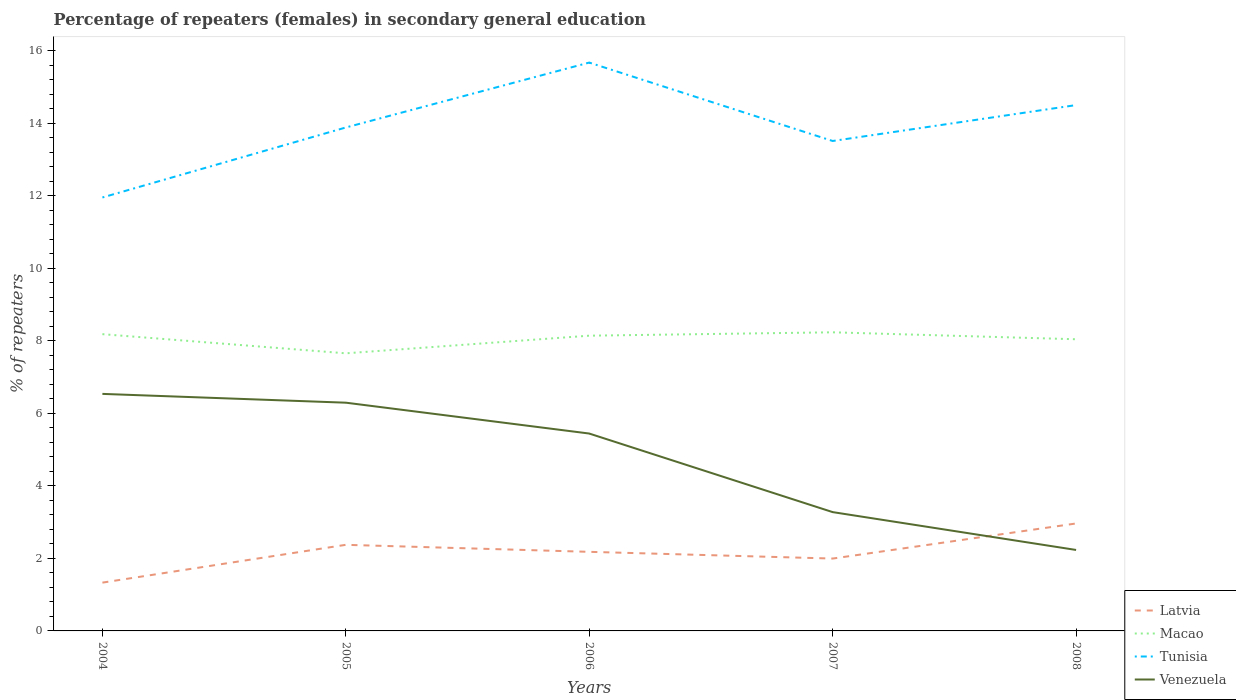Does the line corresponding to Tunisia intersect with the line corresponding to Latvia?
Keep it short and to the point. No. Is the number of lines equal to the number of legend labels?
Your answer should be compact. Yes. Across all years, what is the maximum percentage of female repeaters in Venezuela?
Offer a very short reply. 2.23. In which year was the percentage of female repeaters in Latvia maximum?
Make the answer very short. 2004. What is the total percentage of female repeaters in Venezuela in the graph?
Ensure brevity in your answer.  2.17. What is the difference between the highest and the second highest percentage of female repeaters in Macao?
Your response must be concise. 0.58. What is the difference between the highest and the lowest percentage of female repeaters in Tunisia?
Provide a short and direct response. 2. How many years are there in the graph?
Offer a very short reply. 5. Does the graph contain any zero values?
Offer a terse response. No. Where does the legend appear in the graph?
Make the answer very short. Bottom right. How many legend labels are there?
Offer a terse response. 4. What is the title of the graph?
Your response must be concise. Percentage of repeaters (females) in secondary general education. Does "Croatia" appear as one of the legend labels in the graph?
Ensure brevity in your answer.  No. What is the label or title of the X-axis?
Ensure brevity in your answer.  Years. What is the label or title of the Y-axis?
Your answer should be compact. % of repeaters. What is the % of repeaters in Latvia in 2004?
Your answer should be compact. 1.33. What is the % of repeaters of Macao in 2004?
Your response must be concise. 8.19. What is the % of repeaters of Tunisia in 2004?
Offer a terse response. 11.96. What is the % of repeaters of Venezuela in 2004?
Offer a terse response. 6.54. What is the % of repeaters of Latvia in 2005?
Keep it short and to the point. 2.38. What is the % of repeaters of Macao in 2005?
Ensure brevity in your answer.  7.66. What is the % of repeaters of Tunisia in 2005?
Keep it short and to the point. 13.89. What is the % of repeaters in Venezuela in 2005?
Provide a short and direct response. 6.3. What is the % of repeaters of Latvia in 2006?
Provide a succinct answer. 2.18. What is the % of repeaters in Macao in 2006?
Offer a very short reply. 8.14. What is the % of repeaters of Tunisia in 2006?
Your response must be concise. 15.68. What is the % of repeaters in Venezuela in 2006?
Offer a very short reply. 5.44. What is the % of repeaters in Latvia in 2007?
Make the answer very short. 2. What is the % of repeaters in Macao in 2007?
Provide a short and direct response. 8.24. What is the % of repeaters of Tunisia in 2007?
Keep it short and to the point. 13.52. What is the % of repeaters of Venezuela in 2007?
Offer a terse response. 3.28. What is the % of repeaters in Latvia in 2008?
Provide a short and direct response. 2.96. What is the % of repeaters in Macao in 2008?
Your answer should be compact. 8.05. What is the % of repeaters of Tunisia in 2008?
Provide a succinct answer. 14.51. What is the % of repeaters of Venezuela in 2008?
Make the answer very short. 2.23. Across all years, what is the maximum % of repeaters of Latvia?
Offer a very short reply. 2.96. Across all years, what is the maximum % of repeaters of Macao?
Your response must be concise. 8.24. Across all years, what is the maximum % of repeaters of Tunisia?
Your answer should be compact. 15.68. Across all years, what is the maximum % of repeaters of Venezuela?
Keep it short and to the point. 6.54. Across all years, what is the minimum % of repeaters in Latvia?
Keep it short and to the point. 1.33. Across all years, what is the minimum % of repeaters of Macao?
Your answer should be compact. 7.66. Across all years, what is the minimum % of repeaters in Tunisia?
Provide a succinct answer. 11.96. Across all years, what is the minimum % of repeaters in Venezuela?
Your answer should be compact. 2.23. What is the total % of repeaters of Latvia in the graph?
Offer a terse response. 10.85. What is the total % of repeaters in Macao in the graph?
Make the answer very short. 40.27. What is the total % of repeaters in Tunisia in the graph?
Your answer should be very brief. 69.55. What is the total % of repeaters in Venezuela in the graph?
Your answer should be compact. 23.79. What is the difference between the % of repeaters of Latvia in 2004 and that in 2005?
Give a very brief answer. -1.04. What is the difference between the % of repeaters in Macao in 2004 and that in 2005?
Give a very brief answer. 0.53. What is the difference between the % of repeaters in Tunisia in 2004 and that in 2005?
Ensure brevity in your answer.  -1.93. What is the difference between the % of repeaters of Venezuela in 2004 and that in 2005?
Provide a succinct answer. 0.24. What is the difference between the % of repeaters of Latvia in 2004 and that in 2006?
Give a very brief answer. -0.85. What is the difference between the % of repeaters in Macao in 2004 and that in 2006?
Provide a short and direct response. 0.04. What is the difference between the % of repeaters in Tunisia in 2004 and that in 2006?
Make the answer very short. -3.72. What is the difference between the % of repeaters of Venezuela in 2004 and that in 2006?
Offer a very short reply. 1.09. What is the difference between the % of repeaters of Latvia in 2004 and that in 2007?
Provide a short and direct response. -0.66. What is the difference between the % of repeaters of Macao in 2004 and that in 2007?
Offer a very short reply. -0.05. What is the difference between the % of repeaters in Tunisia in 2004 and that in 2007?
Provide a succinct answer. -1.56. What is the difference between the % of repeaters of Venezuela in 2004 and that in 2007?
Provide a succinct answer. 3.26. What is the difference between the % of repeaters in Latvia in 2004 and that in 2008?
Make the answer very short. -1.63. What is the difference between the % of repeaters in Macao in 2004 and that in 2008?
Provide a short and direct response. 0.14. What is the difference between the % of repeaters of Tunisia in 2004 and that in 2008?
Keep it short and to the point. -2.55. What is the difference between the % of repeaters of Venezuela in 2004 and that in 2008?
Ensure brevity in your answer.  4.31. What is the difference between the % of repeaters in Latvia in 2005 and that in 2006?
Provide a succinct answer. 0.19. What is the difference between the % of repeaters of Macao in 2005 and that in 2006?
Give a very brief answer. -0.49. What is the difference between the % of repeaters in Tunisia in 2005 and that in 2006?
Ensure brevity in your answer.  -1.79. What is the difference between the % of repeaters of Venezuela in 2005 and that in 2006?
Provide a short and direct response. 0.85. What is the difference between the % of repeaters of Latvia in 2005 and that in 2007?
Your response must be concise. 0.38. What is the difference between the % of repeaters of Macao in 2005 and that in 2007?
Provide a short and direct response. -0.58. What is the difference between the % of repeaters of Tunisia in 2005 and that in 2007?
Make the answer very short. 0.37. What is the difference between the % of repeaters of Venezuela in 2005 and that in 2007?
Provide a succinct answer. 3.02. What is the difference between the % of repeaters of Latvia in 2005 and that in 2008?
Ensure brevity in your answer.  -0.59. What is the difference between the % of repeaters in Macao in 2005 and that in 2008?
Your response must be concise. -0.39. What is the difference between the % of repeaters of Tunisia in 2005 and that in 2008?
Your response must be concise. -0.62. What is the difference between the % of repeaters in Venezuela in 2005 and that in 2008?
Provide a succinct answer. 4.06. What is the difference between the % of repeaters in Latvia in 2006 and that in 2007?
Your answer should be compact. 0.19. What is the difference between the % of repeaters in Macao in 2006 and that in 2007?
Ensure brevity in your answer.  -0.09. What is the difference between the % of repeaters of Tunisia in 2006 and that in 2007?
Your answer should be compact. 2.16. What is the difference between the % of repeaters in Venezuela in 2006 and that in 2007?
Provide a succinct answer. 2.17. What is the difference between the % of repeaters of Latvia in 2006 and that in 2008?
Your answer should be compact. -0.78. What is the difference between the % of repeaters in Macao in 2006 and that in 2008?
Keep it short and to the point. 0.1. What is the difference between the % of repeaters in Tunisia in 2006 and that in 2008?
Your answer should be compact. 1.17. What is the difference between the % of repeaters in Venezuela in 2006 and that in 2008?
Offer a terse response. 3.21. What is the difference between the % of repeaters in Latvia in 2007 and that in 2008?
Offer a very short reply. -0.97. What is the difference between the % of repeaters of Macao in 2007 and that in 2008?
Offer a very short reply. 0.19. What is the difference between the % of repeaters in Tunisia in 2007 and that in 2008?
Your answer should be very brief. -0.99. What is the difference between the % of repeaters in Venezuela in 2007 and that in 2008?
Offer a very short reply. 1.04. What is the difference between the % of repeaters of Latvia in 2004 and the % of repeaters of Macao in 2005?
Your answer should be very brief. -6.33. What is the difference between the % of repeaters of Latvia in 2004 and the % of repeaters of Tunisia in 2005?
Offer a very short reply. -12.56. What is the difference between the % of repeaters in Latvia in 2004 and the % of repeaters in Venezuela in 2005?
Your answer should be compact. -4.96. What is the difference between the % of repeaters of Macao in 2004 and the % of repeaters of Tunisia in 2005?
Give a very brief answer. -5.7. What is the difference between the % of repeaters of Macao in 2004 and the % of repeaters of Venezuela in 2005?
Your response must be concise. 1.89. What is the difference between the % of repeaters in Tunisia in 2004 and the % of repeaters in Venezuela in 2005?
Offer a terse response. 5.66. What is the difference between the % of repeaters in Latvia in 2004 and the % of repeaters in Macao in 2006?
Make the answer very short. -6.81. What is the difference between the % of repeaters in Latvia in 2004 and the % of repeaters in Tunisia in 2006?
Ensure brevity in your answer.  -14.35. What is the difference between the % of repeaters of Latvia in 2004 and the % of repeaters of Venezuela in 2006?
Give a very brief answer. -4.11. What is the difference between the % of repeaters in Macao in 2004 and the % of repeaters in Tunisia in 2006?
Make the answer very short. -7.49. What is the difference between the % of repeaters of Macao in 2004 and the % of repeaters of Venezuela in 2006?
Provide a succinct answer. 2.74. What is the difference between the % of repeaters in Tunisia in 2004 and the % of repeaters in Venezuela in 2006?
Ensure brevity in your answer.  6.51. What is the difference between the % of repeaters in Latvia in 2004 and the % of repeaters in Macao in 2007?
Make the answer very short. -6.91. What is the difference between the % of repeaters of Latvia in 2004 and the % of repeaters of Tunisia in 2007?
Offer a very short reply. -12.18. What is the difference between the % of repeaters of Latvia in 2004 and the % of repeaters of Venezuela in 2007?
Keep it short and to the point. -1.95. What is the difference between the % of repeaters in Macao in 2004 and the % of repeaters in Tunisia in 2007?
Keep it short and to the point. -5.33. What is the difference between the % of repeaters of Macao in 2004 and the % of repeaters of Venezuela in 2007?
Your answer should be very brief. 4.91. What is the difference between the % of repeaters in Tunisia in 2004 and the % of repeaters in Venezuela in 2007?
Your answer should be compact. 8.68. What is the difference between the % of repeaters in Latvia in 2004 and the % of repeaters in Macao in 2008?
Your answer should be very brief. -6.71. What is the difference between the % of repeaters of Latvia in 2004 and the % of repeaters of Tunisia in 2008?
Your answer should be very brief. -13.17. What is the difference between the % of repeaters in Latvia in 2004 and the % of repeaters in Venezuela in 2008?
Provide a short and direct response. -0.9. What is the difference between the % of repeaters in Macao in 2004 and the % of repeaters in Tunisia in 2008?
Ensure brevity in your answer.  -6.32. What is the difference between the % of repeaters in Macao in 2004 and the % of repeaters in Venezuela in 2008?
Your answer should be very brief. 5.95. What is the difference between the % of repeaters in Tunisia in 2004 and the % of repeaters in Venezuela in 2008?
Offer a terse response. 9.72. What is the difference between the % of repeaters of Latvia in 2005 and the % of repeaters of Macao in 2006?
Keep it short and to the point. -5.77. What is the difference between the % of repeaters in Latvia in 2005 and the % of repeaters in Tunisia in 2006?
Your answer should be compact. -13.3. What is the difference between the % of repeaters of Latvia in 2005 and the % of repeaters of Venezuela in 2006?
Give a very brief answer. -3.07. What is the difference between the % of repeaters of Macao in 2005 and the % of repeaters of Tunisia in 2006?
Ensure brevity in your answer.  -8.02. What is the difference between the % of repeaters in Macao in 2005 and the % of repeaters in Venezuela in 2006?
Offer a very short reply. 2.21. What is the difference between the % of repeaters of Tunisia in 2005 and the % of repeaters of Venezuela in 2006?
Make the answer very short. 8.44. What is the difference between the % of repeaters in Latvia in 2005 and the % of repeaters in Macao in 2007?
Provide a short and direct response. -5.86. What is the difference between the % of repeaters of Latvia in 2005 and the % of repeaters of Tunisia in 2007?
Your answer should be very brief. -11.14. What is the difference between the % of repeaters of Latvia in 2005 and the % of repeaters of Venezuela in 2007?
Offer a very short reply. -0.9. What is the difference between the % of repeaters of Macao in 2005 and the % of repeaters of Tunisia in 2007?
Provide a short and direct response. -5.86. What is the difference between the % of repeaters of Macao in 2005 and the % of repeaters of Venezuela in 2007?
Give a very brief answer. 4.38. What is the difference between the % of repeaters of Tunisia in 2005 and the % of repeaters of Venezuela in 2007?
Your answer should be compact. 10.61. What is the difference between the % of repeaters of Latvia in 2005 and the % of repeaters of Macao in 2008?
Your answer should be very brief. -5.67. What is the difference between the % of repeaters in Latvia in 2005 and the % of repeaters in Tunisia in 2008?
Your answer should be compact. -12.13. What is the difference between the % of repeaters of Latvia in 2005 and the % of repeaters of Venezuela in 2008?
Make the answer very short. 0.14. What is the difference between the % of repeaters of Macao in 2005 and the % of repeaters of Tunisia in 2008?
Give a very brief answer. -6.85. What is the difference between the % of repeaters of Macao in 2005 and the % of repeaters of Venezuela in 2008?
Ensure brevity in your answer.  5.42. What is the difference between the % of repeaters in Tunisia in 2005 and the % of repeaters in Venezuela in 2008?
Ensure brevity in your answer.  11.65. What is the difference between the % of repeaters in Latvia in 2006 and the % of repeaters in Macao in 2007?
Your answer should be compact. -6.06. What is the difference between the % of repeaters in Latvia in 2006 and the % of repeaters in Tunisia in 2007?
Offer a terse response. -11.33. What is the difference between the % of repeaters of Latvia in 2006 and the % of repeaters of Venezuela in 2007?
Your answer should be compact. -1.1. What is the difference between the % of repeaters of Macao in 2006 and the % of repeaters of Tunisia in 2007?
Your response must be concise. -5.37. What is the difference between the % of repeaters of Macao in 2006 and the % of repeaters of Venezuela in 2007?
Your answer should be compact. 4.87. What is the difference between the % of repeaters of Tunisia in 2006 and the % of repeaters of Venezuela in 2007?
Give a very brief answer. 12.4. What is the difference between the % of repeaters of Latvia in 2006 and the % of repeaters of Macao in 2008?
Provide a short and direct response. -5.86. What is the difference between the % of repeaters in Latvia in 2006 and the % of repeaters in Tunisia in 2008?
Your answer should be very brief. -12.32. What is the difference between the % of repeaters in Latvia in 2006 and the % of repeaters in Venezuela in 2008?
Your response must be concise. -0.05. What is the difference between the % of repeaters of Macao in 2006 and the % of repeaters of Tunisia in 2008?
Provide a succinct answer. -6.36. What is the difference between the % of repeaters in Macao in 2006 and the % of repeaters in Venezuela in 2008?
Give a very brief answer. 5.91. What is the difference between the % of repeaters of Tunisia in 2006 and the % of repeaters of Venezuela in 2008?
Offer a very short reply. 13.45. What is the difference between the % of repeaters of Latvia in 2007 and the % of repeaters of Macao in 2008?
Keep it short and to the point. -6.05. What is the difference between the % of repeaters of Latvia in 2007 and the % of repeaters of Tunisia in 2008?
Keep it short and to the point. -12.51. What is the difference between the % of repeaters in Latvia in 2007 and the % of repeaters in Venezuela in 2008?
Provide a short and direct response. -0.24. What is the difference between the % of repeaters in Macao in 2007 and the % of repeaters in Tunisia in 2008?
Your answer should be very brief. -6.27. What is the difference between the % of repeaters in Macao in 2007 and the % of repeaters in Venezuela in 2008?
Provide a short and direct response. 6. What is the difference between the % of repeaters in Tunisia in 2007 and the % of repeaters in Venezuela in 2008?
Your answer should be compact. 11.28. What is the average % of repeaters in Latvia per year?
Keep it short and to the point. 2.17. What is the average % of repeaters of Macao per year?
Provide a short and direct response. 8.05. What is the average % of repeaters of Tunisia per year?
Offer a very short reply. 13.91. What is the average % of repeaters in Venezuela per year?
Make the answer very short. 4.76. In the year 2004, what is the difference between the % of repeaters in Latvia and % of repeaters in Macao?
Give a very brief answer. -6.85. In the year 2004, what is the difference between the % of repeaters of Latvia and % of repeaters of Tunisia?
Your response must be concise. -10.62. In the year 2004, what is the difference between the % of repeaters in Latvia and % of repeaters in Venezuela?
Offer a very short reply. -5.21. In the year 2004, what is the difference between the % of repeaters in Macao and % of repeaters in Tunisia?
Your answer should be very brief. -3.77. In the year 2004, what is the difference between the % of repeaters in Macao and % of repeaters in Venezuela?
Offer a terse response. 1.65. In the year 2004, what is the difference between the % of repeaters in Tunisia and % of repeaters in Venezuela?
Ensure brevity in your answer.  5.42. In the year 2005, what is the difference between the % of repeaters of Latvia and % of repeaters of Macao?
Provide a short and direct response. -5.28. In the year 2005, what is the difference between the % of repeaters of Latvia and % of repeaters of Tunisia?
Offer a very short reply. -11.51. In the year 2005, what is the difference between the % of repeaters in Latvia and % of repeaters in Venezuela?
Your answer should be compact. -3.92. In the year 2005, what is the difference between the % of repeaters in Macao and % of repeaters in Tunisia?
Make the answer very short. -6.23. In the year 2005, what is the difference between the % of repeaters in Macao and % of repeaters in Venezuela?
Keep it short and to the point. 1.36. In the year 2005, what is the difference between the % of repeaters in Tunisia and % of repeaters in Venezuela?
Your response must be concise. 7.59. In the year 2006, what is the difference between the % of repeaters of Latvia and % of repeaters of Macao?
Give a very brief answer. -5.96. In the year 2006, what is the difference between the % of repeaters in Latvia and % of repeaters in Tunisia?
Your answer should be compact. -13.5. In the year 2006, what is the difference between the % of repeaters in Latvia and % of repeaters in Venezuela?
Your answer should be very brief. -3.26. In the year 2006, what is the difference between the % of repeaters in Macao and % of repeaters in Tunisia?
Give a very brief answer. -7.53. In the year 2006, what is the difference between the % of repeaters in Macao and % of repeaters in Venezuela?
Provide a succinct answer. 2.7. In the year 2006, what is the difference between the % of repeaters of Tunisia and % of repeaters of Venezuela?
Provide a succinct answer. 10.23. In the year 2007, what is the difference between the % of repeaters of Latvia and % of repeaters of Macao?
Your answer should be compact. -6.24. In the year 2007, what is the difference between the % of repeaters of Latvia and % of repeaters of Tunisia?
Make the answer very short. -11.52. In the year 2007, what is the difference between the % of repeaters of Latvia and % of repeaters of Venezuela?
Your answer should be very brief. -1.28. In the year 2007, what is the difference between the % of repeaters of Macao and % of repeaters of Tunisia?
Ensure brevity in your answer.  -5.28. In the year 2007, what is the difference between the % of repeaters in Macao and % of repeaters in Venezuela?
Your response must be concise. 4.96. In the year 2007, what is the difference between the % of repeaters of Tunisia and % of repeaters of Venezuela?
Provide a succinct answer. 10.24. In the year 2008, what is the difference between the % of repeaters in Latvia and % of repeaters in Macao?
Ensure brevity in your answer.  -5.08. In the year 2008, what is the difference between the % of repeaters of Latvia and % of repeaters of Tunisia?
Your response must be concise. -11.54. In the year 2008, what is the difference between the % of repeaters of Latvia and % of repeaters of Venezuela?
Offer a terse response. 0.73. In the year 2008, what is the difference between the % of repeaters of Macao and % of repeaters of Tunisia?
Your answer should be very brief. -6.46. In the year 2008, what is the difference between the % of repeaters in Macao and % of repeaters in Venezuela?
Ensure brevity in your answer.  5.81. In the year 2008, what is the difference between the % of repeaters in Tunisia and % of repeaters in Venezuela?
Offer a terse response. 12.27. What is the ratio of the % of repeaters in Latvia in 2004 to that in 2005?
Keep it short and to the point. 0.56. What is the ratio of the % of repeaters of Macao in 2004 to that in 2005?
Provide a short and direct response. 1.07. What is the ratio of the % of repeaters of Tunisia in 2004 to that in 2005?
Provide a succinct answer. 0.86. What is the ratio of the % of repeaters of Venezuela in 2004 to that in 2005?
Provide a succinct answer. 1.04. What is the ratio of the % of repeaters of Latvia in 2004 to that in 2006?
Make the answer very short. 0.61. What is the ratio of the % of repeaters of Tunisia in 2004 to that in 2006?
Give a very brief answer. 0.76. What is the ratio of the % of repeaters in Venezuela in 2004 to that in 2006?
Your response must be concise. 1.2. What is the ratio of the % of repeaters of Latvia in 2004 to that in 2007?
Your answer should be very brief. 0.67. What is the ratio of the % of repeaters in Macao in 2004 to that in 2007?
Ensure brevity in your answer.  0.99. What is the ratio of the % of repeaters in Tunisia in 2004 to that in 2007?
Offer a terse response. 0.88. What is the ratio of the % of repeaters in Venezuela in 2004 to that in 2007?
Make the answer very short. 2. What is the ratio of the % of repeaters in Latvia in 2004 to that in 2008?
Provide a succinct answer. 0.45. What is the ratio of the % of repeaters in Macao in 2004 to that in 2008?
Offer a terse response. 1.02. What is the ratio of the % of repeaters of Tunisia in 2004 to that in 2008?
Provide a short and direct response. 0.82. What is the ratio of the % of repeaters in Venezuela in 2004 to that in 2008?
Provide a short and direct response. 2.93. What is the ratio of the % of repeaters in Latvia in 2005 to that in 2006?
Your answer should be very brief. 1.09. What is the ratio of the % of repeaters of Macao in 2005 to that in 2006?
Your response must be concise. 0.94. What is the ratio of the % of repeaters in Tunisia in 2005 to that in 2006?
Offer a very short reply. 0.89. What is the ratio of the % of repeaters of Venezuela in 2005 to that in 2006?
Offer a terse response. 1.16. What is the ratio of the % of repeaters in Latvia in 2005 to that in 2007?
Your response must be concise. 1.19. What is the ratio of the % of repeaters of Macao in 2005 to that in 2007?
Keep it short and to the point. 0.93. What is the ratio of the % of repeaters of Tunisia in 2005 to that in 2007?
Offer a very short reply. 1.03. What is the ratio of the % of repeaters in Venezuela in 2005 to that in 2007?
Provide a short and direct response. 1.92. What is the ratio of the % of repeaters of Latvia in 2005 to that in 2008?
Your answer should be very brief. 0.8. What is the ratio of the % of repeaters of Macao in 2005 to that in 2008?
Offer a terse response. 0.95. What is the ratio of the % of repeaters of Tunisia in 2005 to that in 2008?
Ensure brevity in your answer.  0.96. What is the ratio of the % of repeaters of Venezuela in 2005 to that in 2008?
Offer a terse response. 2.82. What is the ratio of the % of repeaters in Latvia in 2006 to that in 2007?
Offer a very short reply. 1.09. What is the ratio of the % of repeaters in Macao in 2006 to that in 2007?
Offer a very short reply. 0.99. What is the ratio of the % of repeaters of Tunisia in 2006 to that in 2007?
Give a very brief answer. 1.16. What is the ratio of the % of repeaters of Venezuela in 2006 to that in 2007?
Provide a short and direct response. 1.66. What is the ratio of the % of repeaters in Latvia in 2006 to that in 2008?
Your answer should be compact. 0.74. What is the ratio of the % of repeaters of Macao in 2006 to that in 2008?
Give a very brief answer. 1.01. What is the ratio of the % of repeaters in Tunisia in 2006 to that in 2008?
Provide a short and direct response. 1.08. What is the ratio of the % of repeaters of Venezuela in 2006 to that in 2008?
Offer a very short reply. 2.44. What is the ratio of the % of repeaters in Latvia in 2007 to that in 2008?
Your answer should be compact. 0.67. What is the ratio of the % of repeaters in Macao in 2007 to that in 2008?
Offer a very short reply. 1.02. What is the ratio of the % of repeaters of Tunisia in 2007 to that in 2008?
Ensure brevity in your answer.  0.93. What is the ratio of the % of repeaters of Venezuela in 2007 to that in 2008?
Provide a succinct answer. 1.47. What is the difference between the highest and the second highest % of repeaters of Latvia?
Provide a short and direct response. 0.59. What is the difference between the highest and the second highest % of repeaters of Macao?
Give a very brief answer. 0.05. What is the difference between the highest and the second highest % of repeaters in Tunisia?
Make the answer very short. 1.17. What is the difference between the highest and the second highest % of repeaters in Venezuela?
Ensure brevity in your answer.  0.24. What is the difference between the highest and the lowest % of repeaters in Latvia?
Provide a short and direct response. 1.63. What is the difference between the highest and the lowest % of repeaters in Macao?
Your answer should be very brief. 0.58. What is the difference between the highest and the lowest % of repeaters of Tunisia?
Offer a very short reply. 3.72. What is the difference between the highest and the lowest % of repeaters in Venezuela?
Your answer should be very brief. 4.31. 